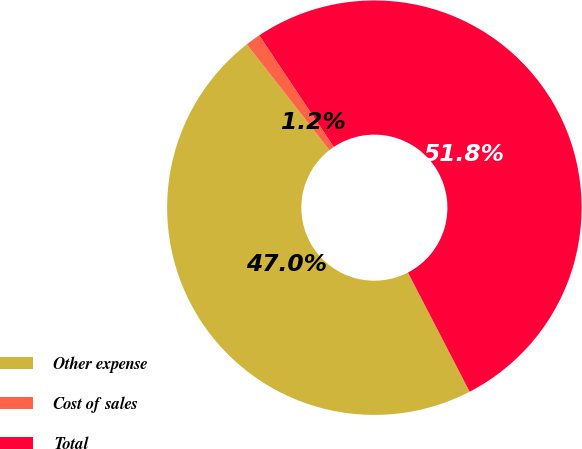<chart> <loc_0><loc_0><loc_500><loc_500><pie_chart><fcel>Other expense<fcel>Cost of sales<fcel>Total<nl><fcel>47.05%<fcel>1.19%<fcel>51.76%<nl></chart> 